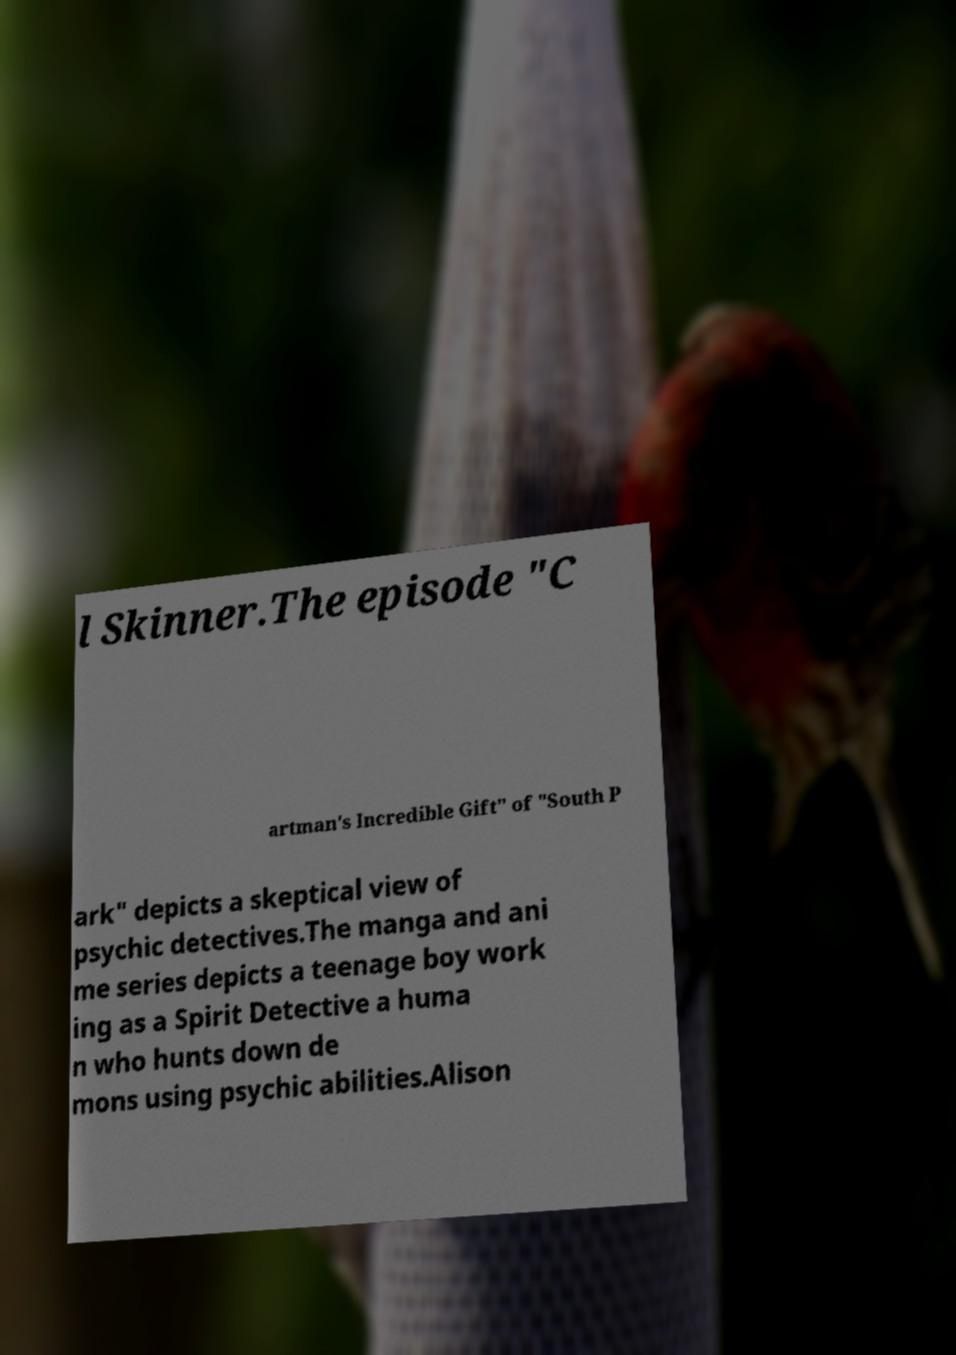I need the written content from this picture converted into text. Can you do that? l Skinner.The episode "C artman's Incredible Gift" of "South P ark" depicts a skeptical view of psychic detectives.The manga and ani me series depicts a teenage boy work ing as a Spirit Detective a huma n who hunts down de mons using psychic abilities.Alison 